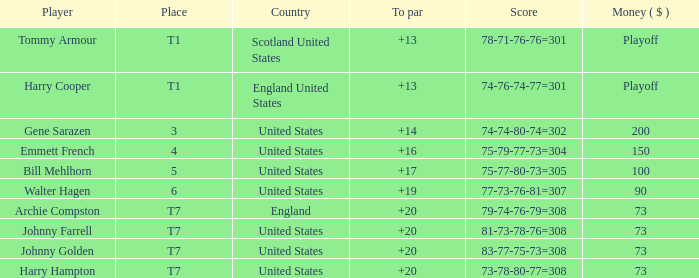What is the score for the United States when Harry Hampton is the player and the money is $73? 73-78-80-77=308. 